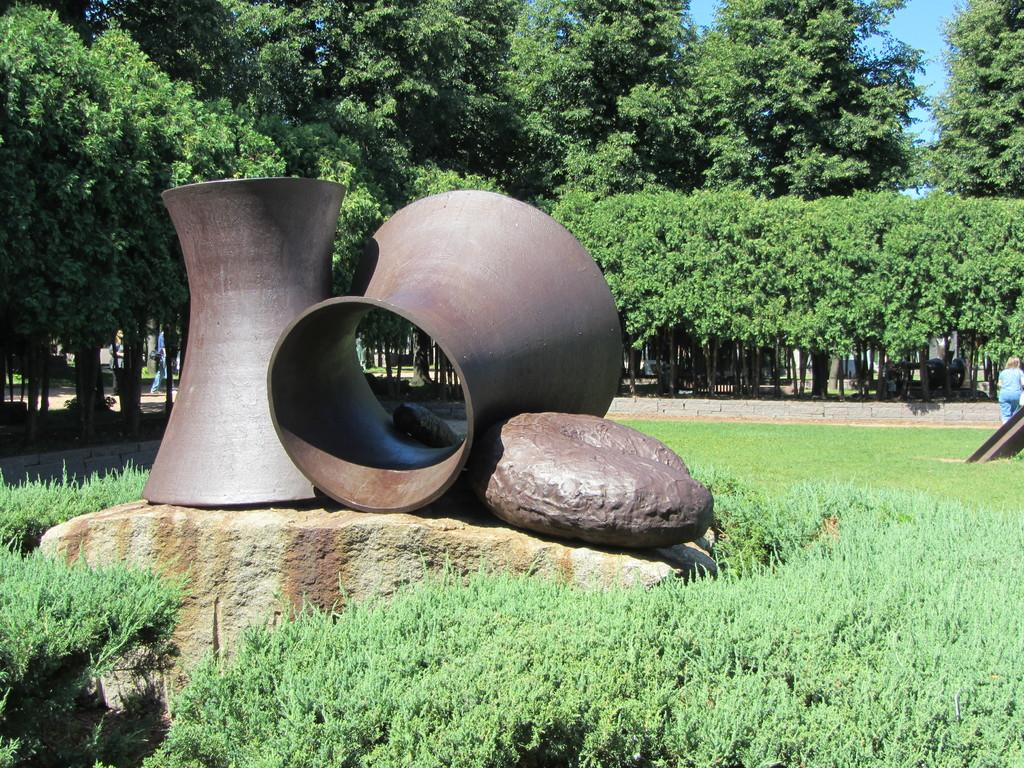What type of vegetation can be seen in the image? There are trees in the image. What part of the natural environment is visible in the image? The sky is visible in the image. Can you describe the people in the image? There are people in the image. What is the color of the grass in the image? Green color grass is present in the image. What color are some of the objects in the image? There are objects in brown color in the image. What type of powder is being used by the people in the image? There is no powder visible in the image, and no indication that the people are using any powder. What answer can be seen written on the trees in the image? There are no answers written on the trees in the image; the trees are simply trees. 